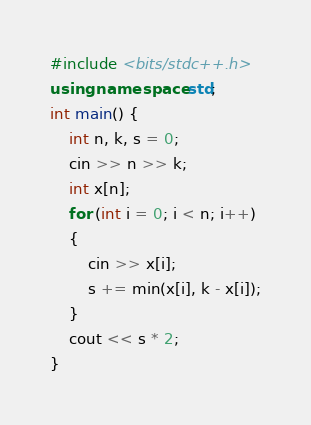Convert code to text. <code><loc_0><loc_0><loc_500><loc_500><_C++_>#include <bits/stdc++.h>
using namespace std;
int main() {
    int n, k, s = 0;
    cin >> n >> k;
    int x[n];
    for (int i = 0; i < n; i++) 
    {
        cin >> x[i];
        s += min(x[i], k - x[i]);
    }
    cout << s * 2;
}</code> 